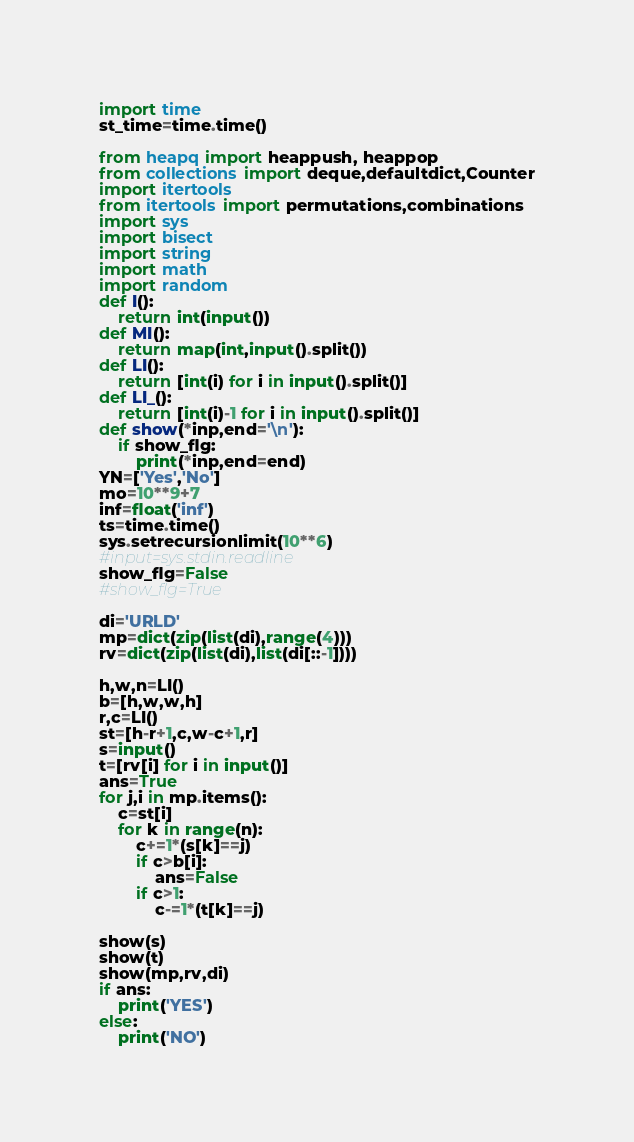Convert code to text. <code><loc_0><loc_0><loc_500><loc_500><_Python_>import time
st_time=time.time()

from heapq import heappush, heappop
from collections import deque,defaultdict,Counter
import itertools
from itertools import permutations,combinations
import sys
import bisect
import string
import math
import random
def I():
    return int(input())
def MI():
    return map(int,input().split())
def LI():
    return [int(i) for i in input().split()]
def LI_():
    return [int(i)-1 for i in input().split()]
def show(*inp,end='\n'):
    if show_flg:
        print(*inp,end=end)
YN=['Yes','No']
mo=10**9+7
inf=float('inf')
ts=time.time()
sys.setrecursionlimit(10**6)
#input=sys.stdin.readline
show_flg=False
#show_flg=True

di='URLD'
mp=dict(zip(list(di),range(4)))
rv=dict(zip(list(di),list(di[::-1])))

h,w,n=LI()
b=[h,w,w,h]
r,c=LI()
st=[h-r+1,c,w-c+1,r]
s=input()
t=[rv[i] for i in input()]
ans=True
for j,i in mp.items():
    c=st[i]
    for k in range(n):
        c+=1*(s[k]==j)
        if c>b[i]:
            ans=False
        if c>1:
            c-=1*(t[k]==j)
            
show(s)
show(t)
show(mp,rv,di)
if ans:
    print('YES')
else:
    print('NO')
</code> 